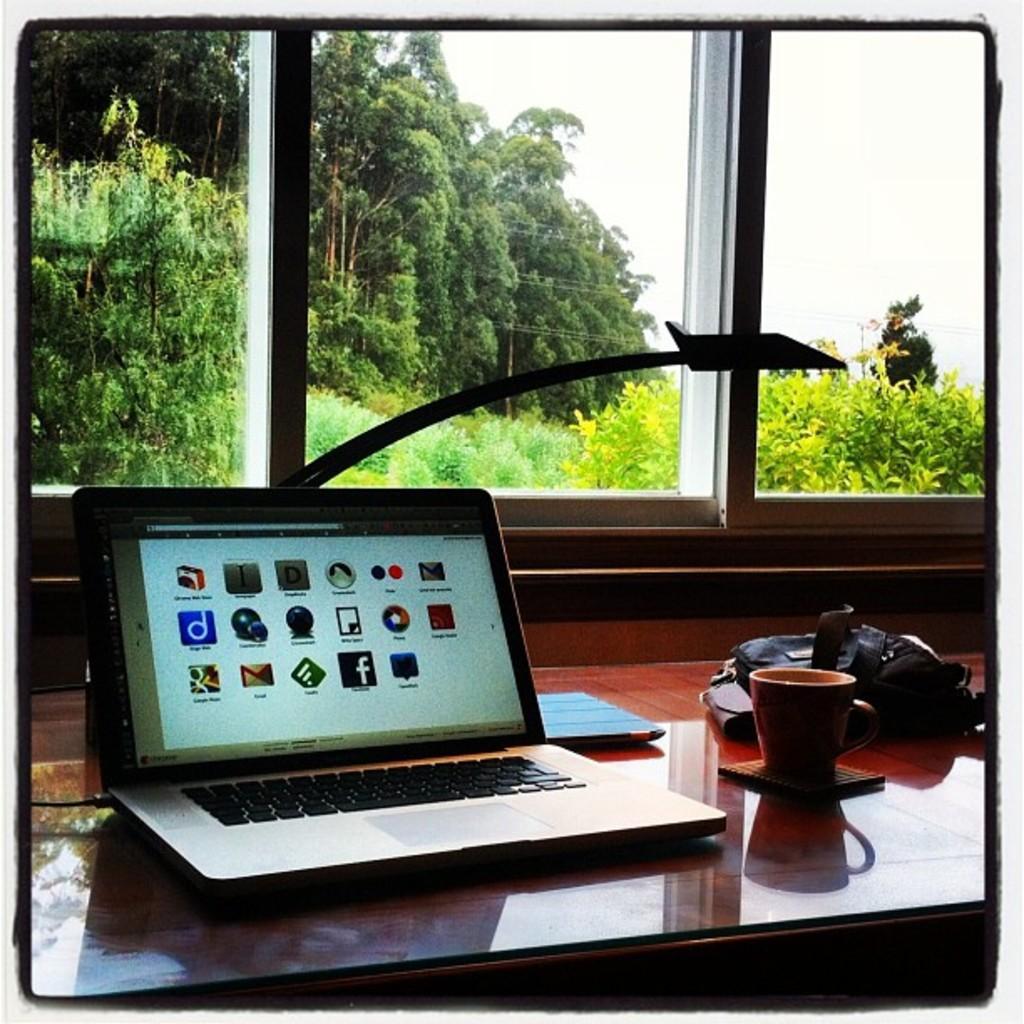In one or two sentences, can you explain what this image depicts? In this image we can see laptop,cup,bag on the table. At the background we can see trees and a sky. 